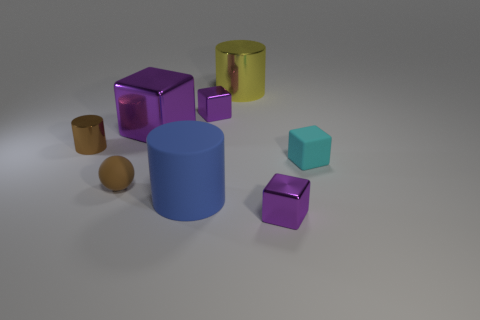How many cyan matte objects are the same shape as the big yellow metal object?
Provide a short and direct response. 0. The big cylinder that is behind the tiny purple block that is behind the blue rubber cylinder is made of what material?
Your answer should be very brief. Metal. What size is the object left of the brown matte thing?
Ensure brevity in your answer.  Small. How many blue objects are big metallic blocks or small objects?
Give a very brief answer. 0. Are there any other things that have the same material as the big yellow cylinder?
Your answer should be compact. Yes. What material is the large purple thing that is the same shape as the tiny cyan object?
Provide a succinct answer. Metal. Are there an equal number of brown spheres on the right side of the cyan block and small cyan rubber blocks?
Provide a succinct answer. No. What size is the cylinder that is both to the right of the matte ball and behind the small brown rubber object?
Offer a terse response. Large. Are there any other things of the same color as the large metallic cylinder?
Your answer should be compact. No. There is a matte object right of the tiny metal object that is in front of the small shiny cylinder; what is its size?
Make the answer very short. Small. 